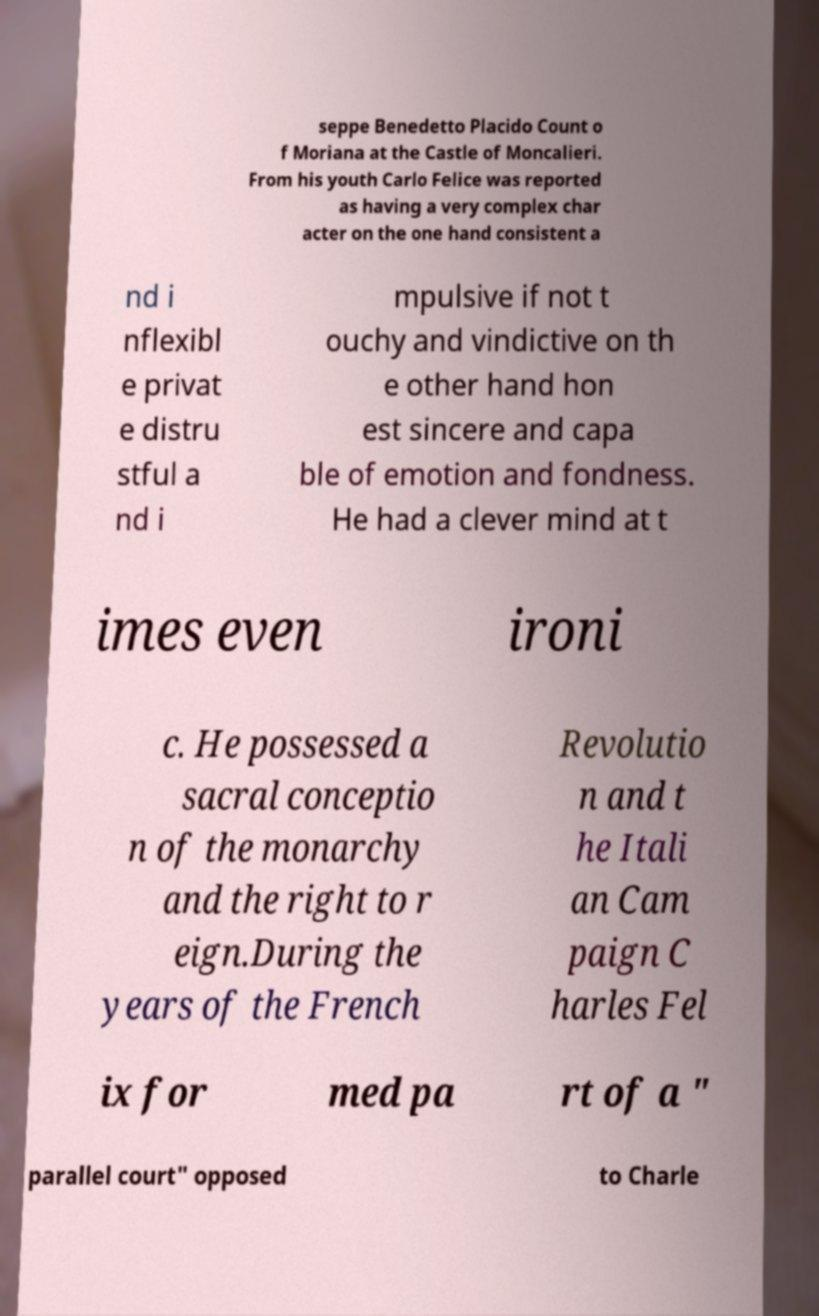Could you extract and type out the text from this image? seppe Benedetto Placido Count o f Moriana at the Castle of Moncalieri. From his youth Carlo Felice was reported as having a very complex char acter on the one hand consistent a nd i nflexibl e privat e distru stful a nd i mpulsive if not t ouchy and vindictive on th e other hand hon est sincere and capa ble of emotion and fondness. He had a clever mind at t imes even ironi c. He possessed a sacral conceptio n of the monarchy and the right to r eign.During the years of the French Revolutio n and t he Itali an Cam paign C harles Fel ix for med pa rt of a " parallel court" opposed to Charle 